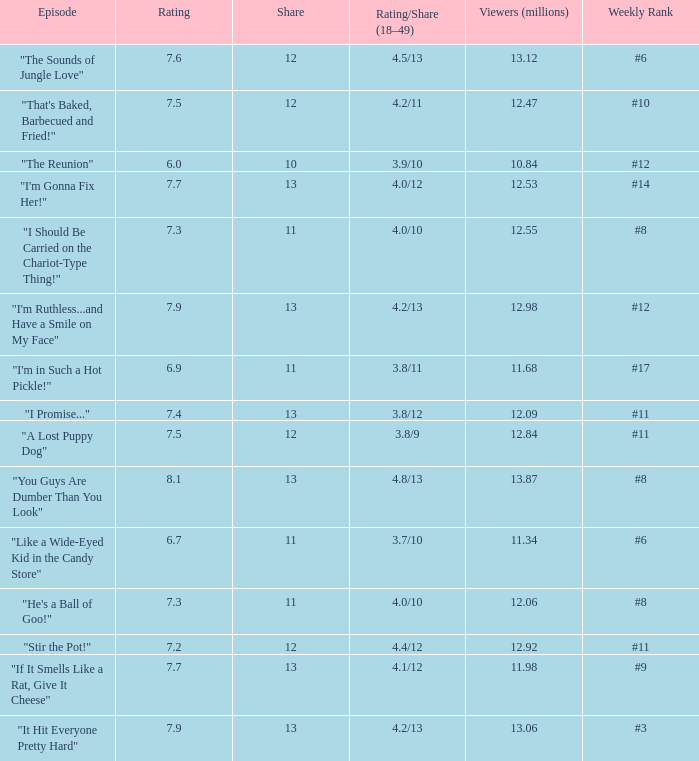Give me the full table as a dictionary. {'header': ['Episode', 'Rating', 'Share', 'Rating/Share (18–49)', 'Viewers (millions)', 'Weekly Rank'], 'rows': [['"The Sounds of Jungle Love"', '7.6', '12', '4.5/13', '13.12', '#6'], ['"That\'s Baked, Barbecued and Fried!"', '7.5', '12', '4.2/11', '12.47', '#10'], ['"The Reunion"', '6.0', '10', '3.9/10', '10.84', '#12'], ['"I\'m Gonna Fix Her!"', '7.7', '13', '4.0/12', '12.53', '#14'], ['"I Should Be Carried on the Chariot-Type Thing!"', '7.3', '11', '4.0/10', '12.55', '#8'], ['"I\'m Ruthless...and Have a Smile on My Face"', '7.9', '13', '4.2/13', '12.98', '#12'], ['"I\'m in Such a Hot Pickle!"', '6.9', '11', '3.8/11', '11.68', '#17'], ['"I Promise..."', '7.4', '13', '3.8/12', '12.09', '#11'], ['"A Lost Puppy Dog"', '7.5', '12', '3.8/9', '12.84', '#11'], ['"You Guys Are Dumber Than You Look"', '8.1', '13', '4.8/13', '13.87', '#8'], ['"Like a Wide-Eyed Kid in the Candy Store"', '6.7', '11', '3.7/10', '11.34', '#6'], ['"He\'s a Ball of Goo!"', '7.3', '11', '4.0/10', '12.06', '#8'], ['"Stir the Pot!"', '7.2', '12', '4.4/12', '12.92', '#11'], ['"If It Smells Like a Rat, Give It Cheese"', '7.7', '13', '4.1/12', '11.98', '#9'], ['"It Hit Everyone Pretty Hard"', '7.9', '13', '4.2/13', '13.06', '#3']]} What is the average rating for "a lost puppy dog"? 7.5. 